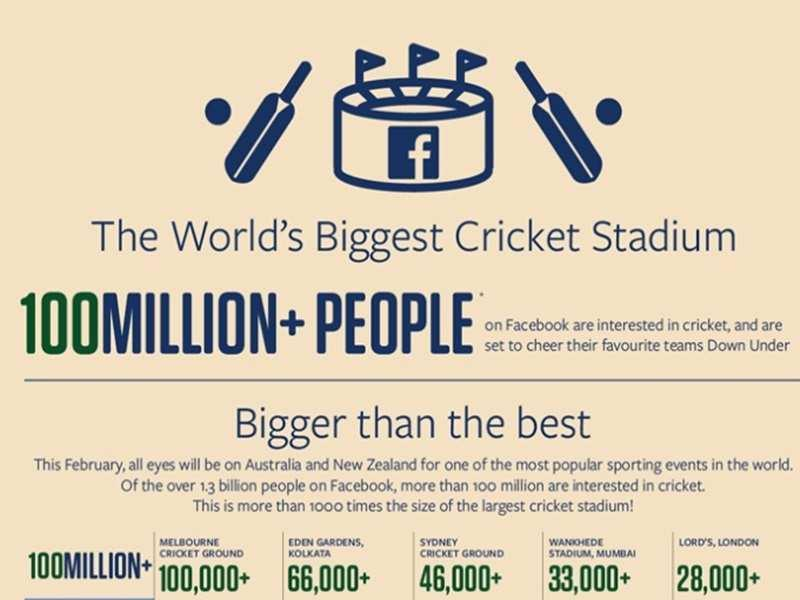Identify some key points in this picture. The capacity of Eden Gardens, Kolkata, is 66,000+. The world's largest cricket stadium is located on Facebook. The Melbourne Cricket Ground has a capacity of 100,000+ people. The total capacity of Wankhede Stadium and Lord's is over 61,000. 